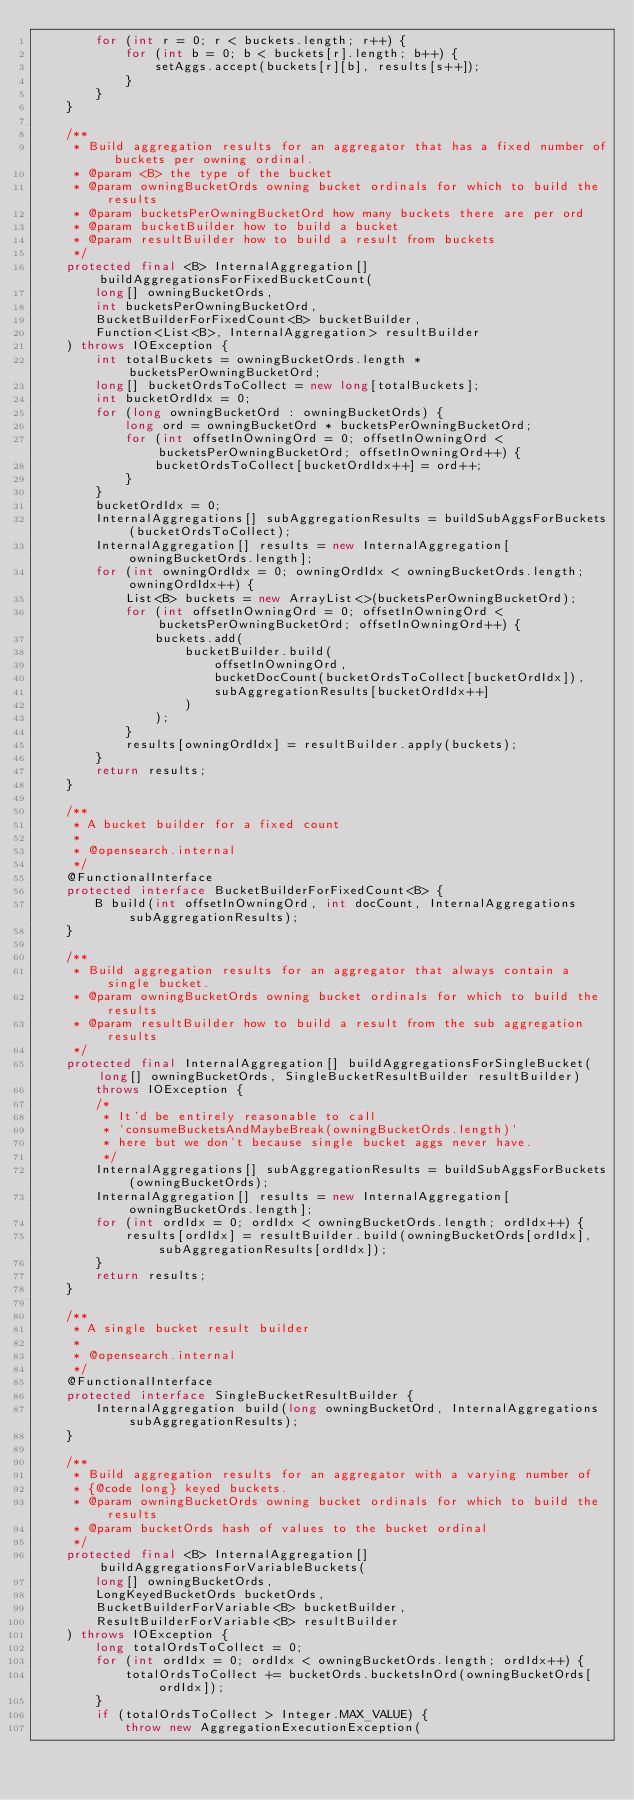Convert code to text. <code><loc_0><loc_0><loc_500><loc_500><_Java_>        for (int r = 0; r < buckets.length; r++) {
            for (int b = 0; b < buckets[r].length; b++) {
                setAggs.accept(buckets[r][b], results[s++]);
            }
        }
    }

    /**
     * Build aggregation results for an aggregator that has a fixed number of buckets per owning ordinal.
     * @param <B> the type of the bucket
     * @param owningBucketOrds owning bucket ordinals for which to build the results
     * @param bucketsPerOwningBucketOrd how many buckets there are per ord
     * @param bucketBuilder how to build a bucket
     * @param resultBuilder how to build a result from buckets
     */
    protected final <B> InternalAggregation[] buildAggregationsForFixedBucketCount(
        long[] owningBucketOrds,
        int bucketsPerOwningBucketOrd,
        BucketBuilderForFixedCount<B> bucketBuilder,
        Function<List<B>, InternalAggregation> resultBuilder
    ) throws IOException {
        int totalBuckets = owningBucketOrds.length * bucketsPerOwningBucketOrd;
        long[] bucketOrdsToCollect = new long[totalBuckets];
        int bucketOrdIdx = 0;
        for (long owningBucketOrd : owningBucketOrds) {
            long ord = owningBucketOrd * bucketsPerOwningBucketOrd;
            for (int offsetInOwningOrd = 0; offsetInOwningOrd < bucketsPerOwningBucketOrd; offsetInOwningOrd++) {
                bucketOrdsToCollect[bucketOrdIdx++] = ord++;
            }
        }
        bucketOrdIdx = 0;
        InternalAggregations[] subAggregationResults = buildSubAggsForBuckets(bucketOrdsToCollect);
        InternalAggregation[] results = new InternalAggregation[owningBucketOrds.length];
        for (int owningOrdIdx = 0; owningOrdIdx < owningBucketOrds.length; owningOrdIdx++) {
            List<B> buckets = new ArrayList<>(bucketsPerOwningBucketOrd);
            for (int offsetInOwningOrd = 0; offsetInOwningOrd < bucketsPerOwningBucketOrd; offsetInOwningOrd++) {
                buckets.add(
                    bucketBuilder.build(
                        offsetInOwningOrd,
                        bucketDocCount(bucketOrdsToCollect[bucketOrdIdx]),
                        subAggregationResults[bucketOrdIdx++]
                    )
                );
            }
            results[owningOrdIdx] = resultBuilder.apply(buckets);
        }
        return results;
    }

    /**
     * A bucket builder for a fixed count
     *
     * @opensearch.internal
     */
    @FunctionalInterface
    protected interface BucketBuilderForFixedCount<B> {
        B build(int offsetInOwningOrd, int docCount, InternalAggregations subAggregationResults);
    }

    /**
     * Build aggregation results for an aggregator that always contain a single bucket.
     * @param owningBucketOrds owning bucket ordinals for which to build the results
     * @param resultBuilder how to build a result from the sub aggregation results
     */
    protected final InternalAggregation[] buildAggregationsForSingleBucket(long[] owningBucketOrds, SingleBucketResultBuilder resultBuilder)
        throws IOException {
        /*
         * It'd be entirely reasonable to call
         * `consumeBucketsAndMaybeBreak(owningBucketOrds.length)`
         * here but we don't because single bucket aggs never have.
         */
        InternalAggregations[] subAggregationResults = buildSubAggsForBuckets(owningBucketOrds);
        InternalAggregation[] results = new InternalAggregation[owningBucketOrds.length];
        for (int ordIdx = 0; ordIdx < owningBucketOrds.length; ordIdx++) {
            results[ordIdx] = resultBuilder.build(owningBucketOrds[ordIdx], subAggregationResults[ordIdx]);
        }
        return results;
    }

    /**
     * A single bucket result builder
     *
     * @opensearch.internal
     */
    @FunctionalInterface
    protected interface SingleBucketResultBuilder {
        InternalAggregation build(long owningBucketOrd, InternalAggregations subAggregationResults);
    }

    /**
     * Build aggregation results for an aggregator with a varying number of
     * {@code long} keyed buckets.
     * @param owningBucketOrds owning bucket ordinals for which to build the results
     * @param bucketOrds hash of values to the bucket ordinal
     */
    protected final <B> InternalAggregation[] buildAggregationsForVariableBuckets(
        long[] owningBucketOrds,
        LongKeyedBucketOrds bucketOrds,
        BucketBuilderForVariable<B> bucketBuilder,
        ResultBuilderForVariable<B> resultBuilder
    ) throws IOException {
        long totalOrdsToCollect = 0;
        for (int ordIdx = 0; ordIdx < owningBucketOrds.length; ordIdx++) {
            totalOrdsToCollect += bucketOrds.bucketsInOrd(owningBucketOrds[ordIdx]);
        }
        if (totalOrdsToCollect > Integer.MAX_VALUE) {
            throw new AggregationExecutionException(</code> 